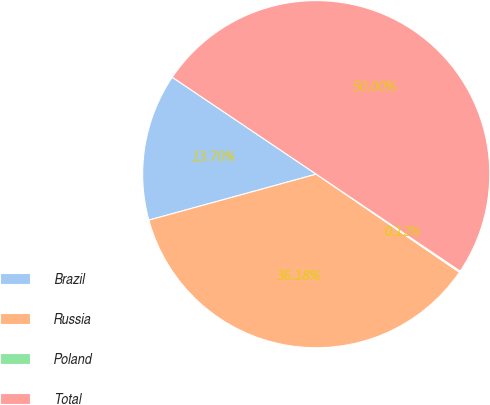Convert chart to OTSL. <chart><loc_0><loc_0><loc_500><loc_500><pie_chart><fcel>Brazil<fcel>Russia<fcel>Poland<fcel>Total<nl><fcel>13.7%<fcel>36.18%<fcel>0.12%<fcel>50.0%<nl></chart> 